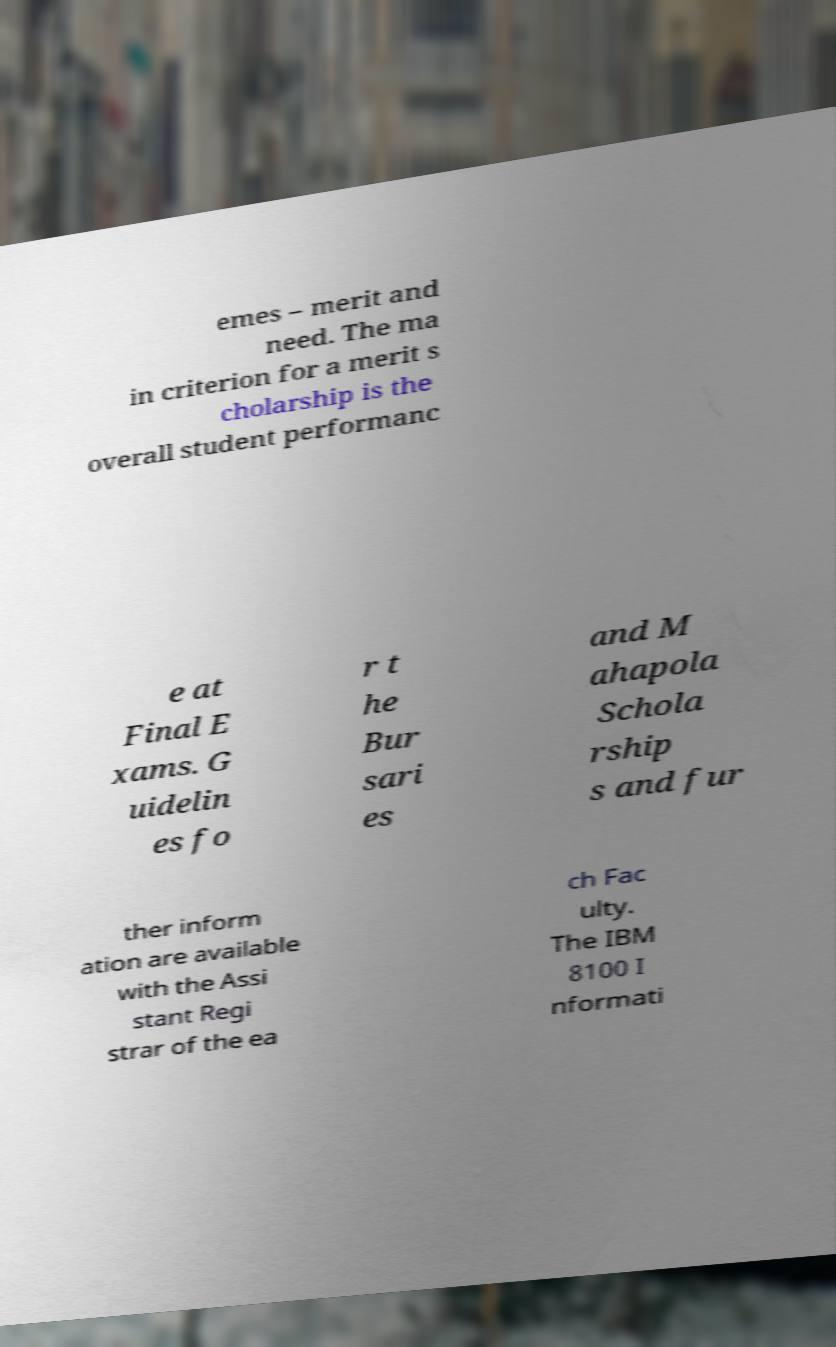Could you extract and type out the text from this image? emes – merit and need. The ma in criterion for a merit s cholarship is the overall student performanc e at Final E xams. G uidelin es fo r t he Bur sari es and M ahapola Schola rship s and fur ther inform ation are available with the Assi stant Regi strar of the ea ch Fac ulty. The IBM 8100 I nformati 